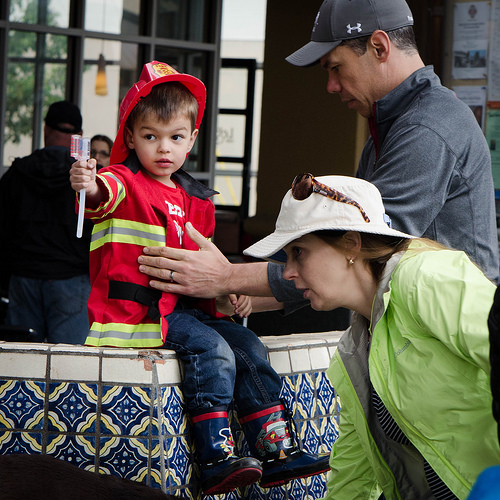<image>
Can you confirm if the child is behind the tiles? No. The child is not behind the tiles. From this viewpoint, the child appears to be positioned elsewhere in the scene. 